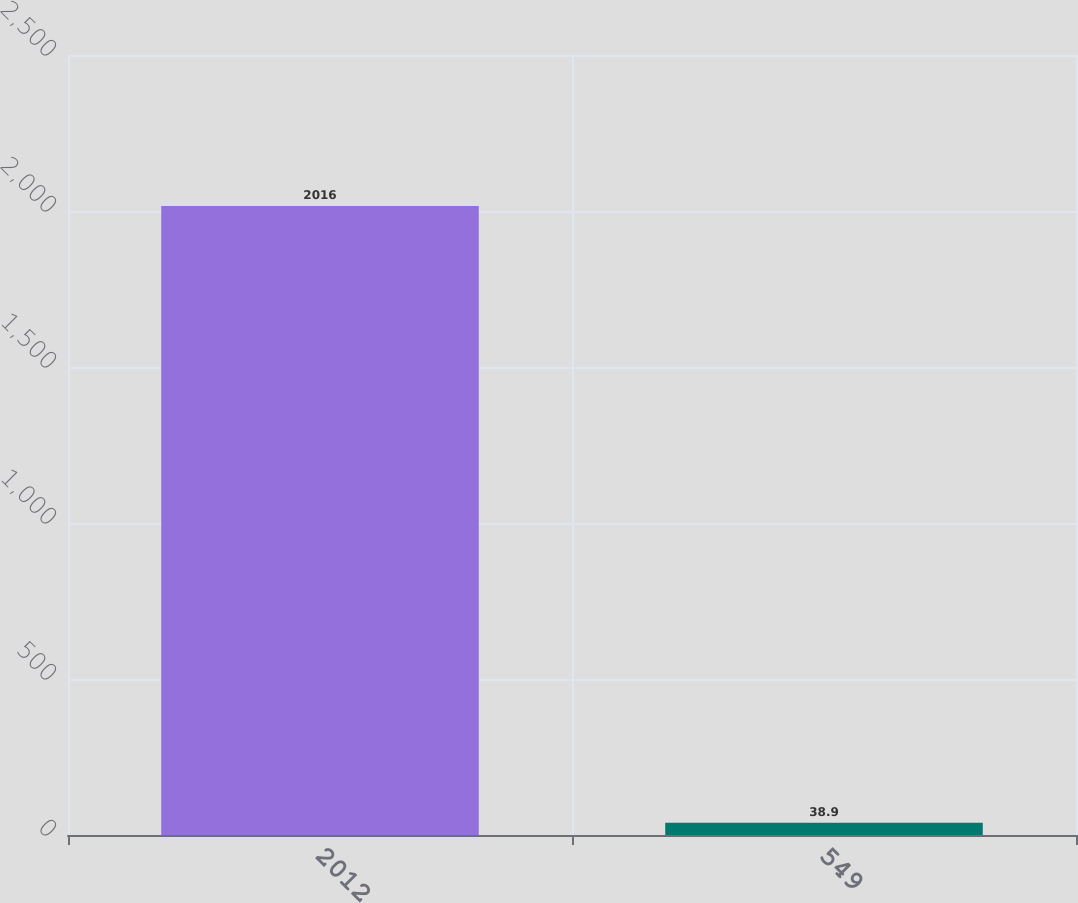Convert chart. <chart><loc_0><loc_0><loc_500><loc_500><bar_chart><fcel>2012<fcel>549<nl><fcel>2016<fcel>38.9<nl></chart> 